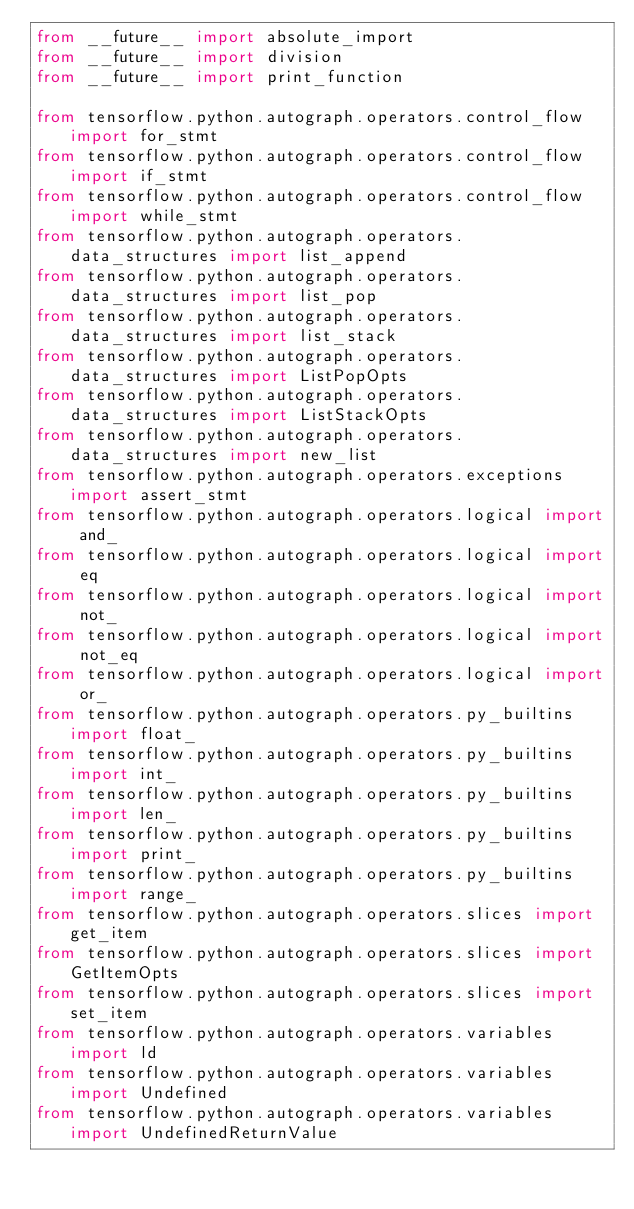Convert code to text. <code><loc_0><loc_0><loc_500><loc_500><_Python_>from __future__ import absolute_import
from __future__ import division
from __future__ import print_function

from tensorflow.python.autograph.operators.control_flow import for_stmt
from tensorflow.python.autograph.operators.control_flow import if_stmt
from tensorflow.python.autograph.operators.control_flow import while_stmt
from tensorflow.python.autograph.operators.data_structures import list_append
from tensorflow.python.autograph.operators.data_structures import list_pop
from tensorflow.python.autograph.operators.data_structures import list_stack
from tensorflow.python.autograph.operators.data_structures import ListPopOpts
from tensorflow.python.autograph.operators.data_structures import ListStackOpts
from tensorflow.python.autograph.operators.data_structures import new_list
from tensorflow.python.autograph.operators.exceptions import assert_stmt
from tensorflow.python.autograph.operators.logical import and_
from tensorflow.python.autograph.operators.logical import eq
from tensorflow.python.autograph.operators.logical import not_
from tensorflow.python.autograph.operators.logical import not_eq
from tensorflow.python.autograph.operators.logical import or_
from tensorflow.python.autograph.operators.py_builtins import float_
from tensorflow.python.autograph.operators.py_builtins import int_
from tensorflow.python.autograph.operators.py_builtins import len_
from tensorflow.python.autograph.operators.py_builtins import print_
from tensorflow.python.autograph.operators.py_builtins import range_
from tensorflow.python.autograph.operators.slices import get_item
from tensorflow.python.autograph.operators.slices import GetItemOpts
from tensorflow.python.autograph.operators.slices import set_item
from tensorflow.python.autograph.operators.variables import ld
from tensorflow.python.autograph.operators.variables import Undefined
from tensorflow.python.autograph.operators.variables import UndefinedReturnValue
</code> 